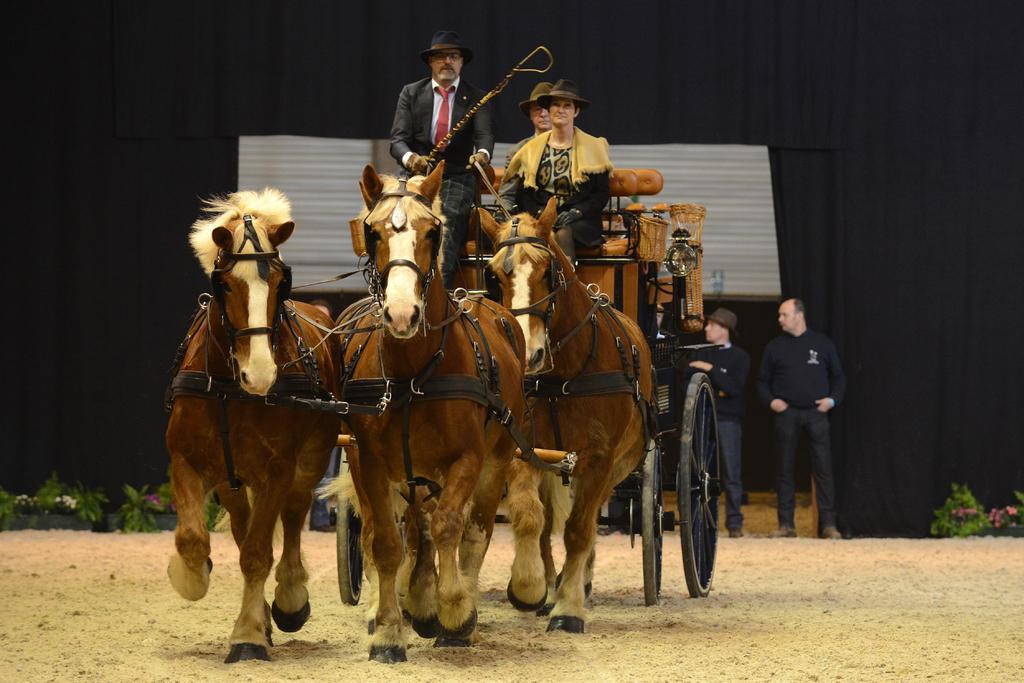Describe this image in one or two sentences. This is a horse cart where a three people are sitting on it. Here we can see a two people standing on the right side. 